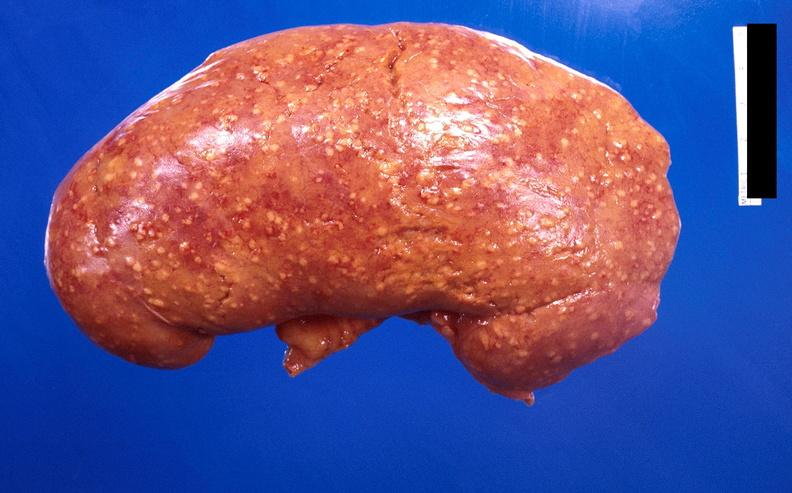where is this?
Answer the question using a single word or phrase. Urinary 